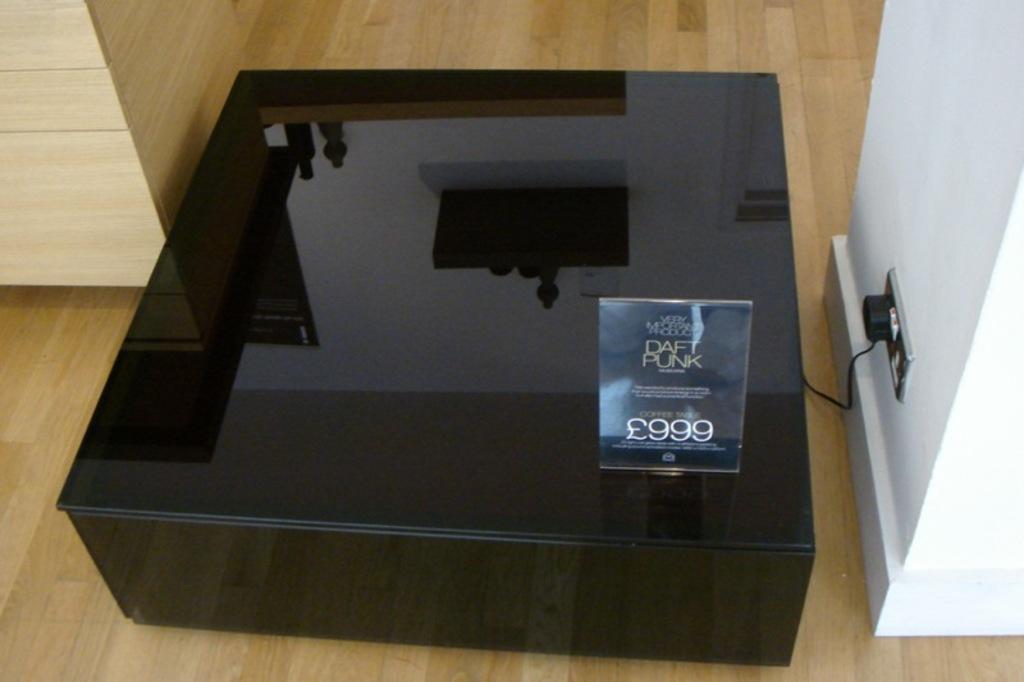How would you summarize this image in a sentence or two? In this image we can see some object which is in black color is on the ground and there is some poster attached to it and the plug is switched into the socket, on right side of the image there is pillar which is of white color and on left side of the image there is wooden color surface. 